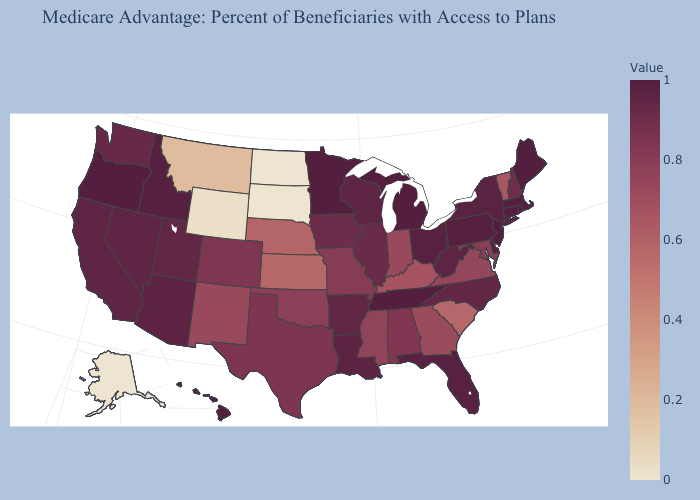Among the states that border North Carolina , which have the highest value?
Short answer required. Tennessee. Which states hav the highest value in the Northeast?
Write a very short answer. Connecticut, Maine, New Jersey, Rhode Island. Which states have the highest value in the USA?
Write a very short answer. Connecticut, Delaware, Maine, Michigan, Minnesota, New Jersey, Oregon, Rhode Island, Tennessee. Which states have the lowest value in the West?
Give a very brief answer. Alaska. Which states have the highest value in the USA?
Quick response, please. Connecticut, Delaware, Maine, Michigan, Minnesota, New Jersey, Oregon, Rhode Island, Tennessee. Does Delaware have the highest value in the USA?
Answer briefly. Yes. 